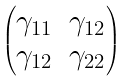<formula> <loc_0><loc_0><loc_500><loc_500>\begin{pmatrix} \gamma _ { 1 1 } & \gamma _ { 1 2 } \\ \gamma _ { 1 2 } & \gamma _ { 2 2 } \end{pmatrix}</formula> 